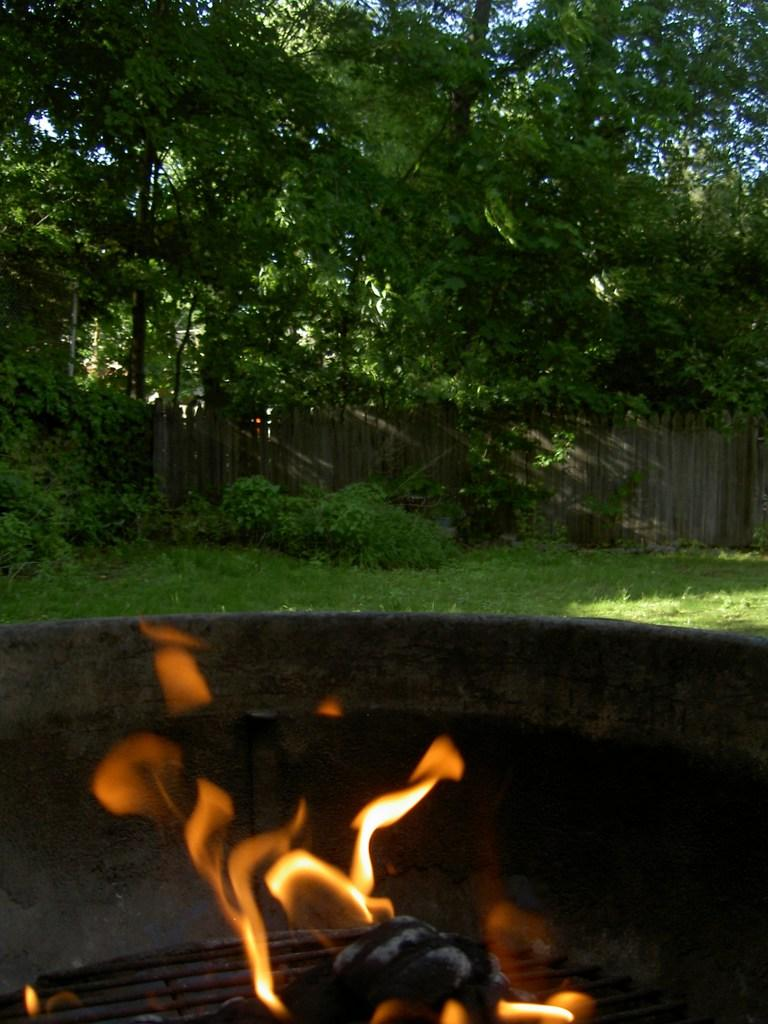What is the main object in the image? There is a grill with fire in the image. What can be seen in the background of the image? There is grass, plants, and trees in the background of the image. What type of fencing is present in the image? There is a wooden fencing in the image. What idea is being discussed by the society in the image? There is no discussion or society present in the image; it features a grill with fire and a background with grass, plants, trees, and wooden fencing. 